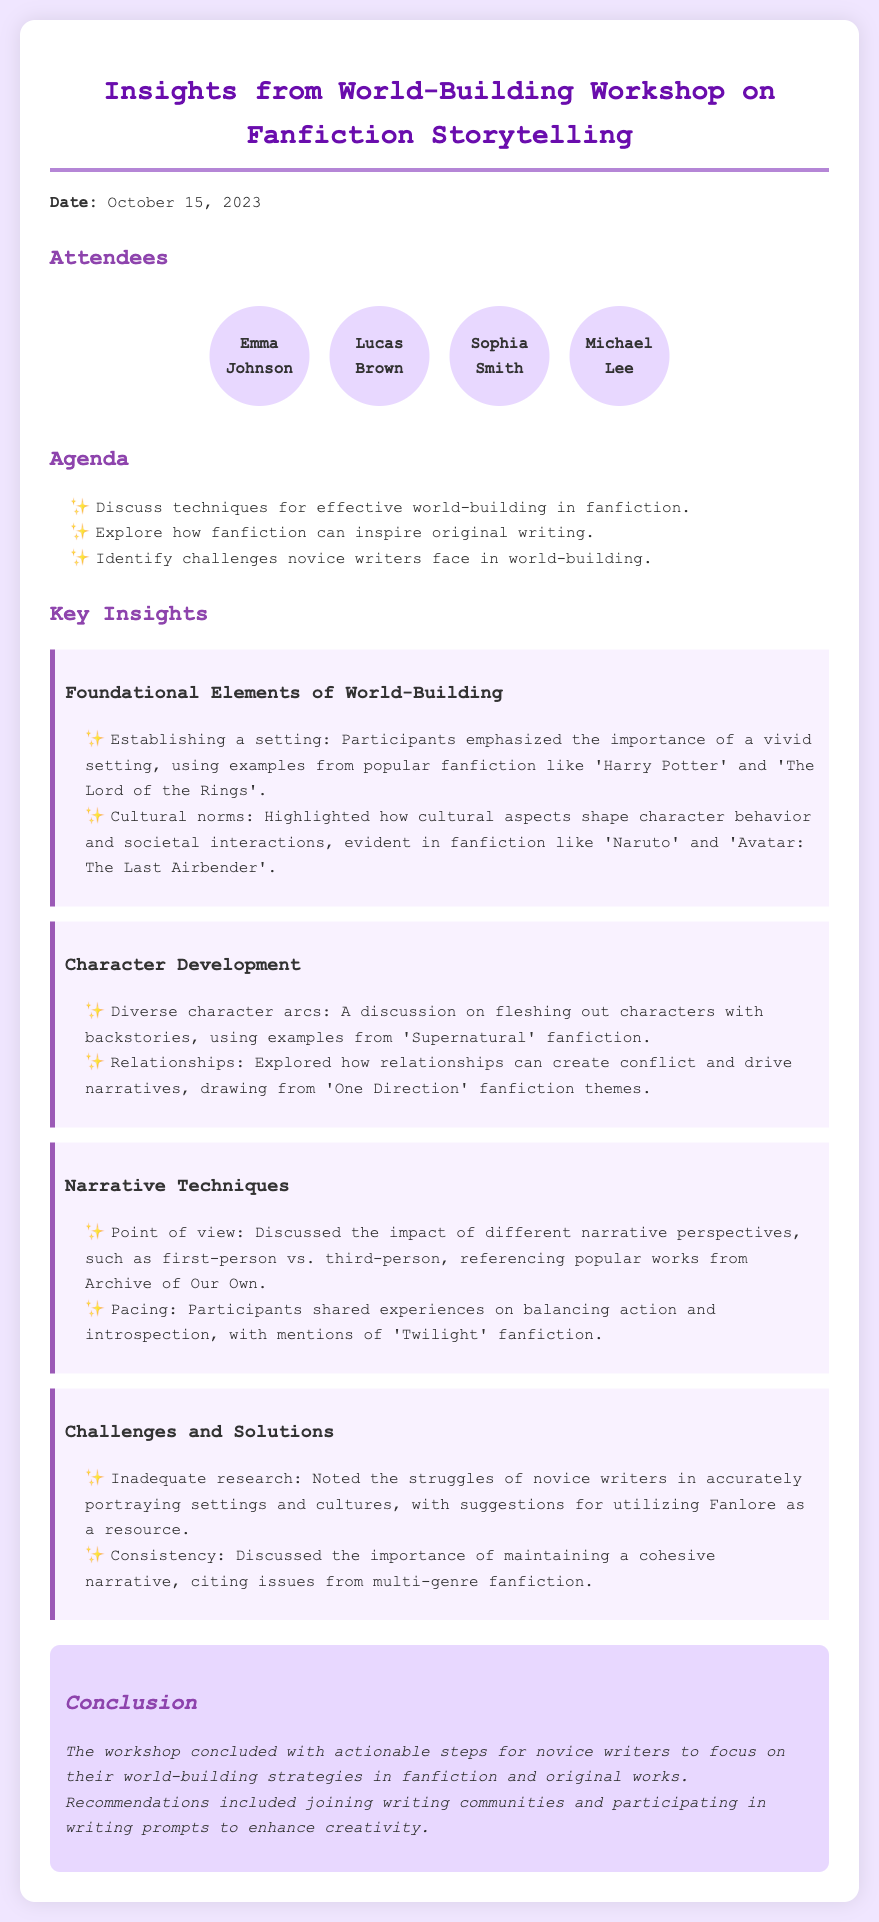What is the date of the workshop? The date of the workshop is specifically mentioned in the document as October 15, 2023.
Answer: October 15, 2023 Who is one of the attendees? The document lists several attendees, including Emma Johnson, Lucas Brown, Sophia Smith, and Michael Lee.
Answer: Emma Johnson What is one key element discussed in world-building? The document highlights establishing a setting as a foundational element of world-building in fanfiction.
Answer: Establishing a setting Which popular fanfiction is referenced in character development discussions? The discussion included examples from 'Supernatural' fanfiction to illustrate diverse character arcs.
Answer: Supernatural What is a challenge novice writers face according to the workshop? The workshop identified inadequate research as a common challenge faced by novice writers in accurately portraying settings and cultures.
Answer: Inadequate research What type of narrative perspective was explored? The workshop discussed the impact of different narrative perspectives, with specific mention of first-person and third-person points of view.
Answer: First-person vs. third-person What actionable step was recommended for novice writers? The conclusion of the workshop provided recommendations for novice writers to join writing communities to enhance their skills.
Answer: Joining writing communities 